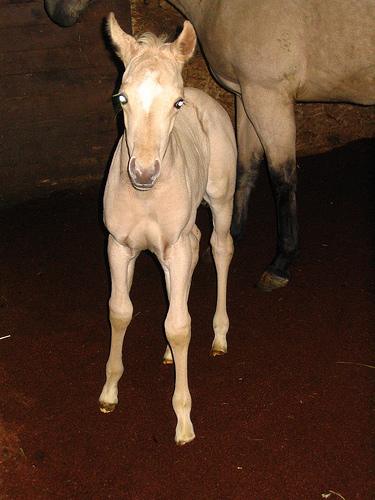<image>
Is there a small horse behind the horse? No. The small horse is not behind the horse. From this viewpoint, the small horse appears to be positioned elsewhere in the scene. 